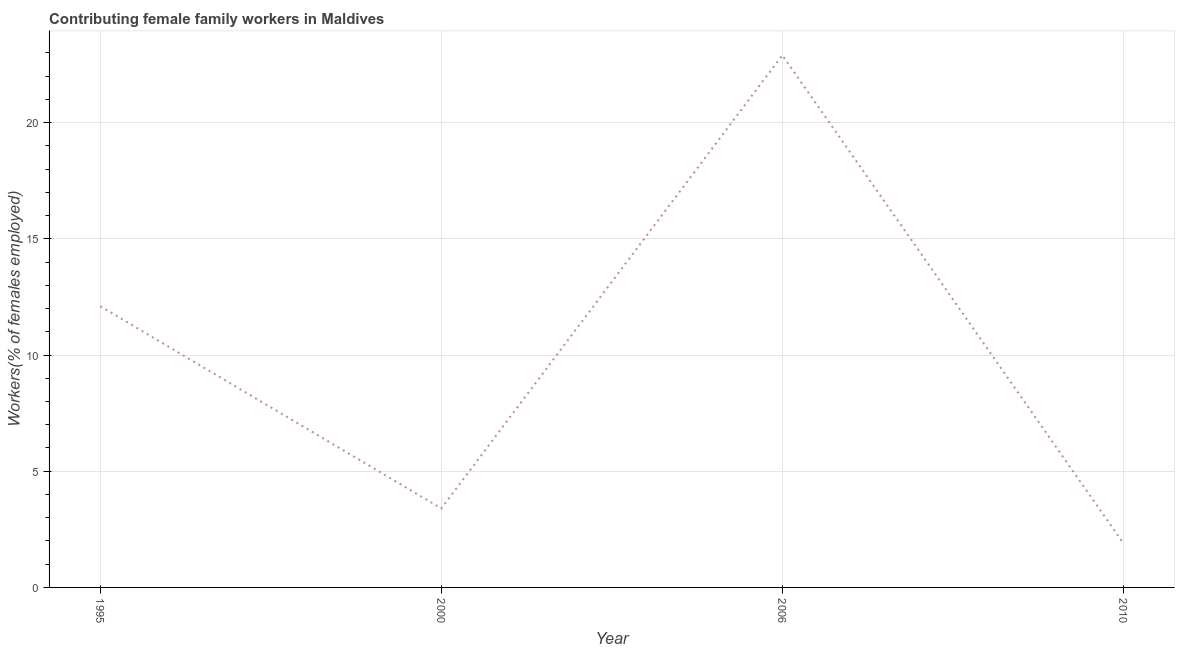What is the contributing female family workers in 1995?
Provide a succinct answer. 12.1. Across all years, what is the maximum contributing female family workers?
Offer a terse response. 22.9. Across all years, what is the minimum contributing female family workers?
Provide a succinct answer. 1.9. In which year was the contributing female family workers maximum?
Offer a very short reply. 2006. What is the sum of the contributing female family workers?
Your answer should be very brief. 40.3. What is the difference between the contributing female family workers in 1995 and 2000?
Ensure brevity in your answer.  8.7. What is the average contributing female family workers per year?
Keep it short and to the point. 10.08. What is the median contributing female family workers?
Keep it short and to the point. 7.75. In how many years, is the contributing female family workers greater than 15 %?
Ensure brevity in your answer.  1. What is the ratio of the contributing female family workers in 1995 to that in 2000?
Your response must be concise. 3.56. Is the difference between the contributing female family workers in 1995 and 2006 greater than the difference between any two years?
Your answer should be compact. No. What is the difference between the highest and the second highest contributing female family workers?
Provide a short and direct response. 10.8. Is the sum of the contributing female family workers in 1995 and 2010 greater than the maximum contributing female family workers across all years?
Your answer should be compact. No. What is the difference between the highest and the lowest contributing female family workers?
Offer a very short reply. 21. How many lines are there?
Your answer should be compact. 1. How many years are there in the graph?
Provide a succinct answer. 4. What is the title of the graph?
Ensure brevity in your answer.  Contributing female family workers in Maldives. What is the label or title of the X-axis?
Make the answer very short. Year. What is the label or title of the Y-axis?
Ensure brevity in your answer.  Workers(% of females employed). What is the Workers(% of females employed) in 1995?
Keep it short and to the point. 12.1. What is the Workers(% of females employed) in 2000?
Offer a terse response. 3.4. What is the Workers(% of females employed) of 2006?
Your answer should be very brief. 22.9. What is the Workers(% of females employed) of 2010?
Your response must be concise. 1.9. What is the difference between the Workers(% of females employed) in 1995 and 2000?
Your answer should be very brief. 8.7. What is the difference between the Workers(% of females employed) in 1995 and 2010?
Provide a short and direct response. 10.2. What is the difference between the Workers(% of females employed) in 2000 and 2006?
Ensure brevity in your answer.  -19.5. What is the difference between the Workers(% of females employed) in 2000 and 2010?
Your response must be concise. 1.5. What is the difference between the Workers(% of females employed) in 2006 and 2010?
Make the answer very short. 21. What is the ratio of the Workers(% of females employed) in 1995 to that in 2000?
Provide a short and direct response. 3.56. What is the ratio of the Workers(% of females employed) in 1995 to that in 2006?
Offer a terse response. 0.53. What is the ratio of the Workers(% of females employed) in 1995 to that in 2010?
Ensure brevity in your answer.  6.37. What is the ratio of the Workers(% of females employed) in 2000 to that in 2006?
Keep it short and to the point. 0.15. What is the ratio of the Workers(% of females employed) in 2000 to that in 2010?
Offer a very short reply. 1.79. What is the ratio of the Workers(% of females employed) in 2006 to that in 2010?
Keep it short and to the point. 12.05. 